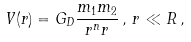Convert formula to latex. <formula><loc_0><loc_0><loc_500><loc_500>V ( r ) = G _ { D } \frac { m _ { 1 } m _ { 2 } } { r ^ { n } r } \, , \, r \ll R \, ,</formula> 